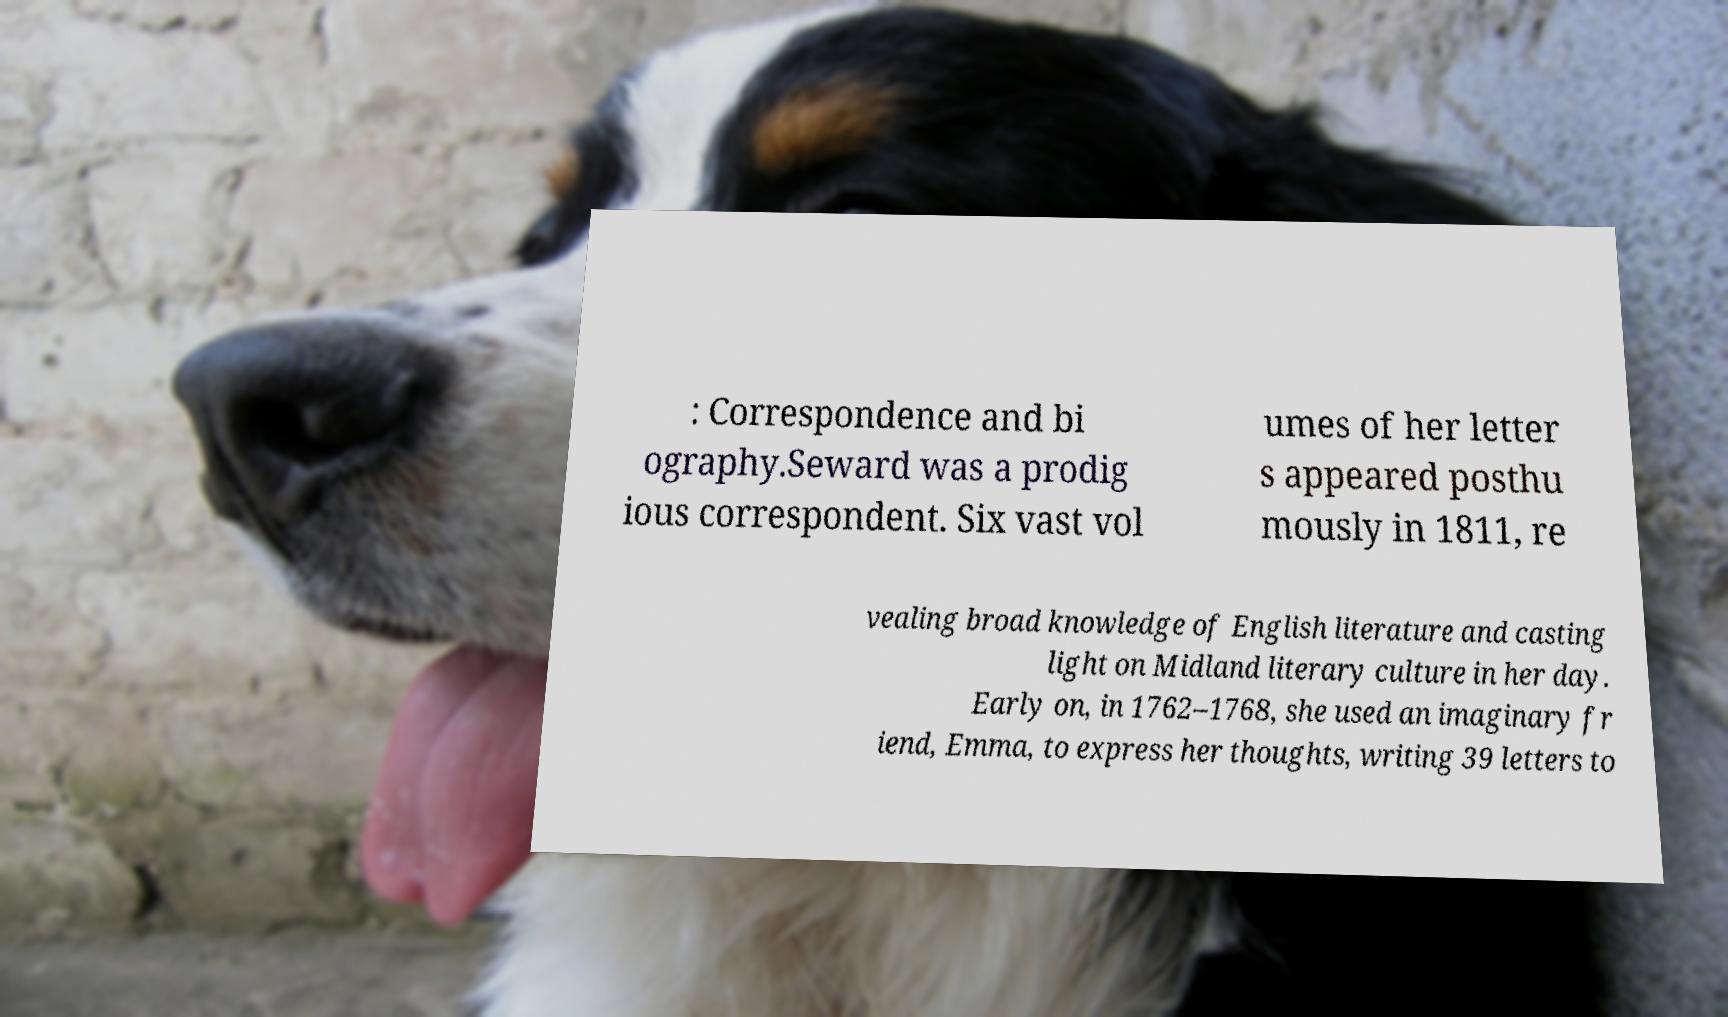For documentation purposes, I need the text within this image transcribed. Could you provide that? : Correspondence and bi ography.Seward was a prodig ious correspondent. Six vast vol umes of her letter s appeared posthu mously in 1811, re vealing broad knowledge of English literature and casting light on Midland literary culture in her day. Early on, in 1762–1768, she used an imaginary fr iend, Emma, to express her thoughts, writing 39 letters to 